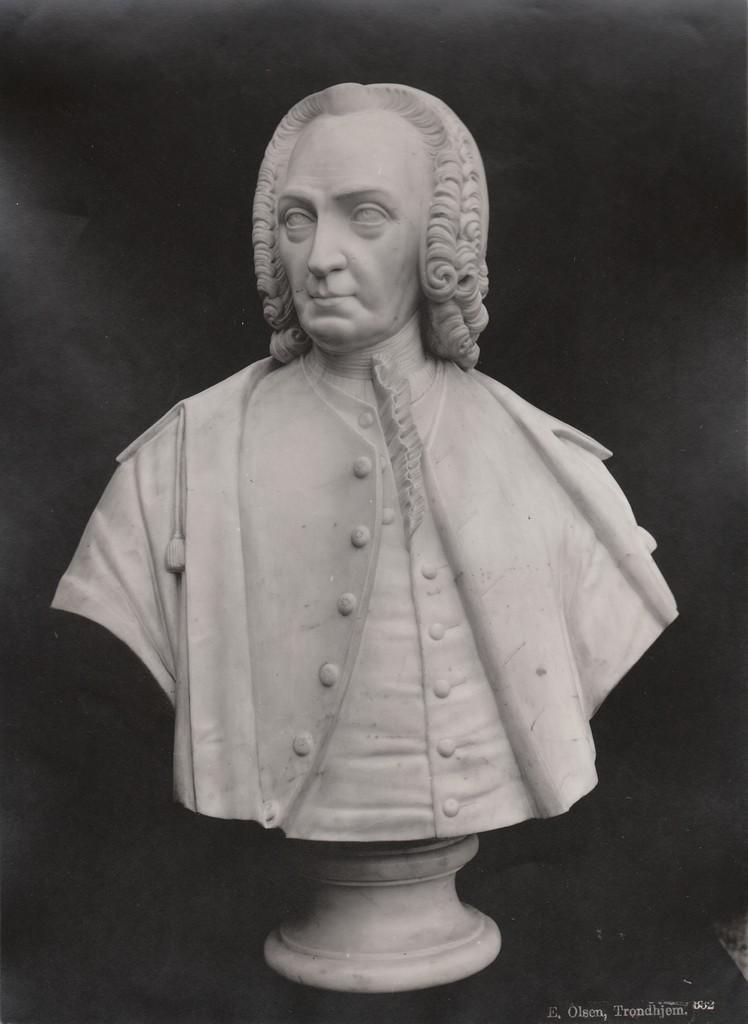Please provide a concise description of this image. In this image we can see a sculpture of a person. The background of the image is dark. Here we can see the watermark on the bottom right side of the image. 